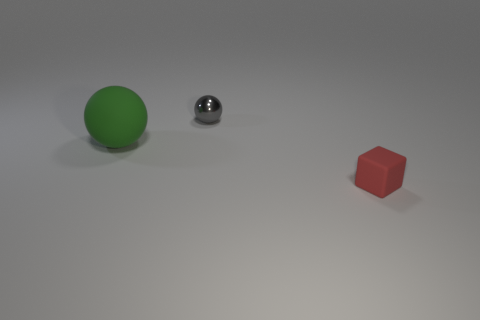Are there any other things that have the same size as the matte ball?
Your response must be concise. No. Is there anything else that has the same material as the gray sphere?
Provide a short and direct response. No. There is a rubber thing behind the small object that is right of the ball behind the green thing; what shape is it?
Keep it short and to the point. Sphere. The rubber object that is the same size as the shiny ball is what color?
Your answer should be very brief. Red. What number of other shiny objects have the same shape as the green object?
Your answer should be compact. 1. Does the red rubber cube have the same size as the ball that is left of the gray shiny object?
Keep it short and to the point. No. There is a small object to the left of the tiny red object on the right side of the big object; what is its shape?
Your answer should be compact. Sphere. Is the number of green matte objects that are right of the tiny gray shiny thing less than the number of large gray cubes?
Your response must be concise. No. How many red rubber things have the same size as the shiny thing?
Offer a terse response. 1. What shape is the small object that is in front of the gray thing?
Your answer should be very brief. Cube. 